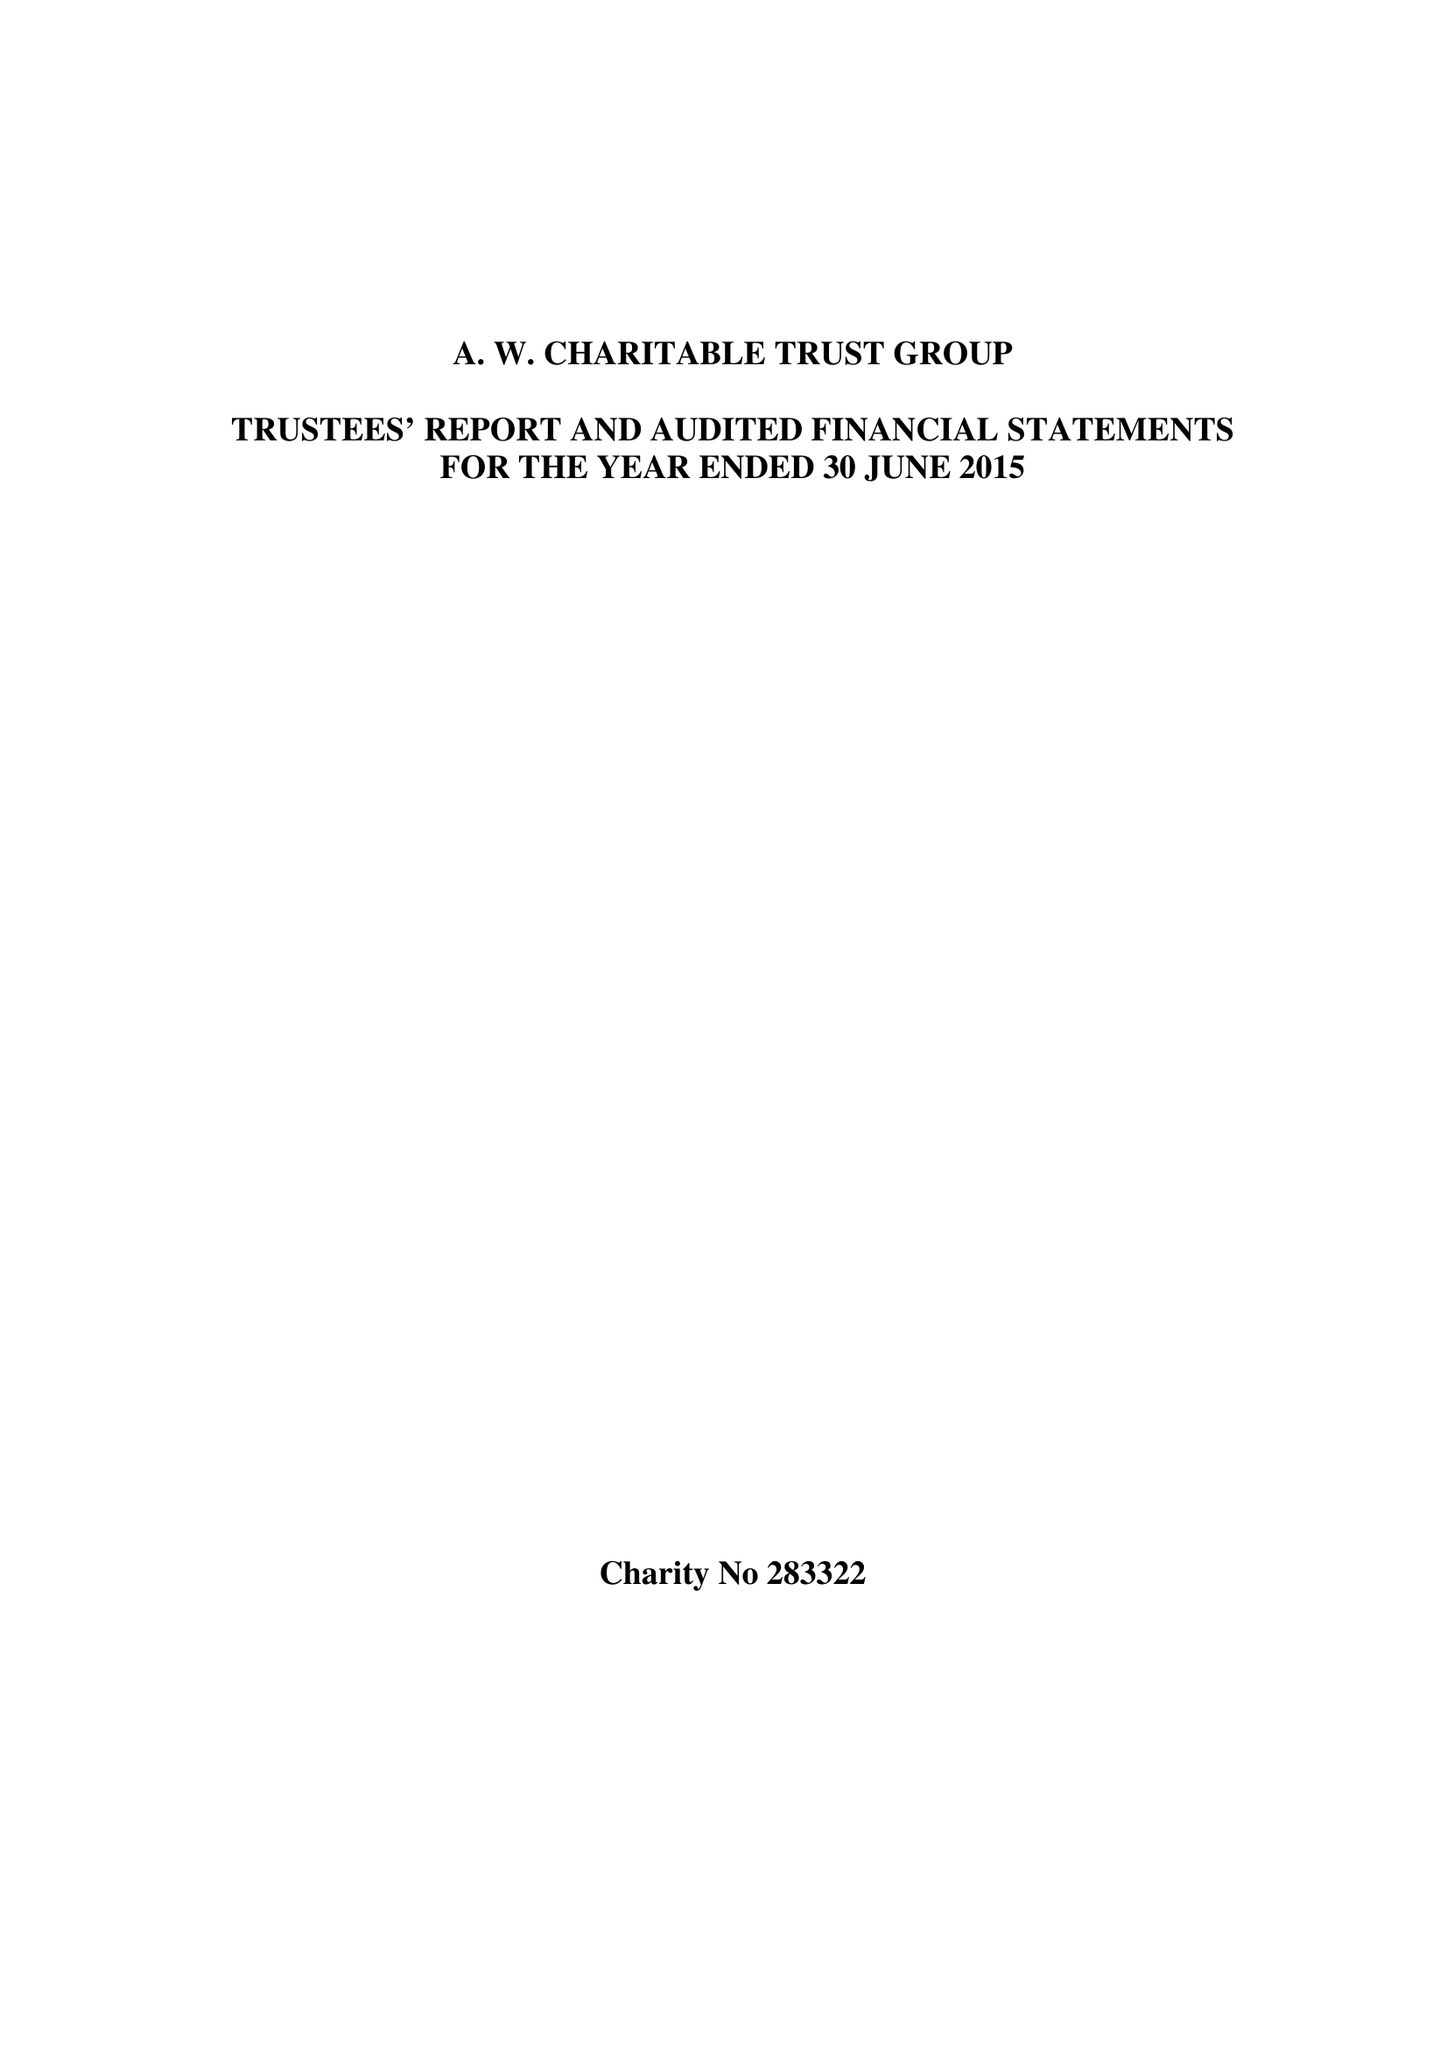What is the value for the income_annually_in_british_pounds?
Answer the question using a single word or phrase. 12826601.00 